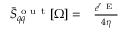<formula> <loc_0><loc_0><loc_500><loc_500>\begin{array} { r l } { \ B a r { S } _ { q q } ^ { o u t } [ \Omega ] = } & \frac { e ^ { r _ { E } } } { 4 \eta } } \end{array}</formula> 